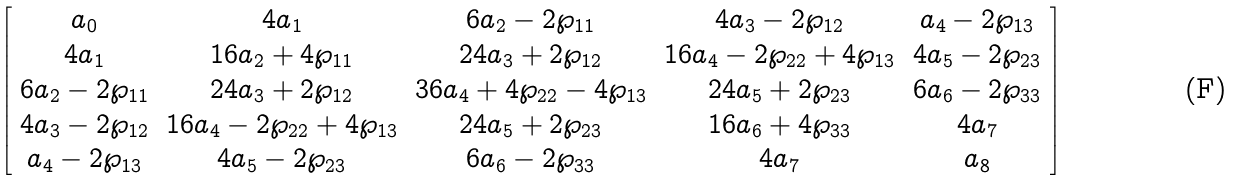Convert formula to latex. <formula><loc_0><loc_0><loc_500><loc_500>\left [ \begin{array} { c c c c c } a _ { 0 } & 4 a _ { 1 } & 6 a _ { 2 } - 2 \wp _ { 1 1 } & 4 a _ { 3 } - 2 \wp _ { 1 2 } & a _ { 4 } - 2 \wp _ { 1 3 } \\ 4 a _ { 1 } & 1 6 a _ { 2 } + 4 \wp _ { 1 1 } & 2 4 a _ { 3 } + 2 \wp _ { 1 2 } & 1 6 a _ { 4 } - 2 \wp _ { 2 2 } + 4 \wp _ { 1 3 } & 4 a _ { 5 } - 2 \wp _ { 2 3 } \\ 6 a _ { 2 } - 2 \wp _ { 1 1 } & 2 4 a _ { 3 } + 2 \wp _ { 1 2 } & 3 6 a _ { 4 } + 4 \wp _ { 2 2 } - 4 \wp _ { 1 3 } & 2 4 a _ { 5 } + 2 \wp _ { 2 3 } & 6 a _ { 6 } - 2 \wp _ { 3 3 } \\ 4 a _ { 3 } - 2 \wp _ { 1 2 } & 1 6 a _ { 4 } - 2 \wp _ { 2 2 } + 4 \wp _ { 1 3 } & 2 4 a _ { 5 } + 2 \wp _ { 2 3 } & 1 6 a _ { 6 } + 4 \wp _ { 3 3 } & 4 a _ { 7 } \\ a _ { 4 } - 2 \wp _ { 1 3 } & 4 a _ { 5 } - 2 \wp _ { 2 3 } & 6 a _ { 6 } - 2 \wp _ { 3 3 } & 4 a _ { 7 } & a _ { 8 } \end{array} \right ]</formula> 